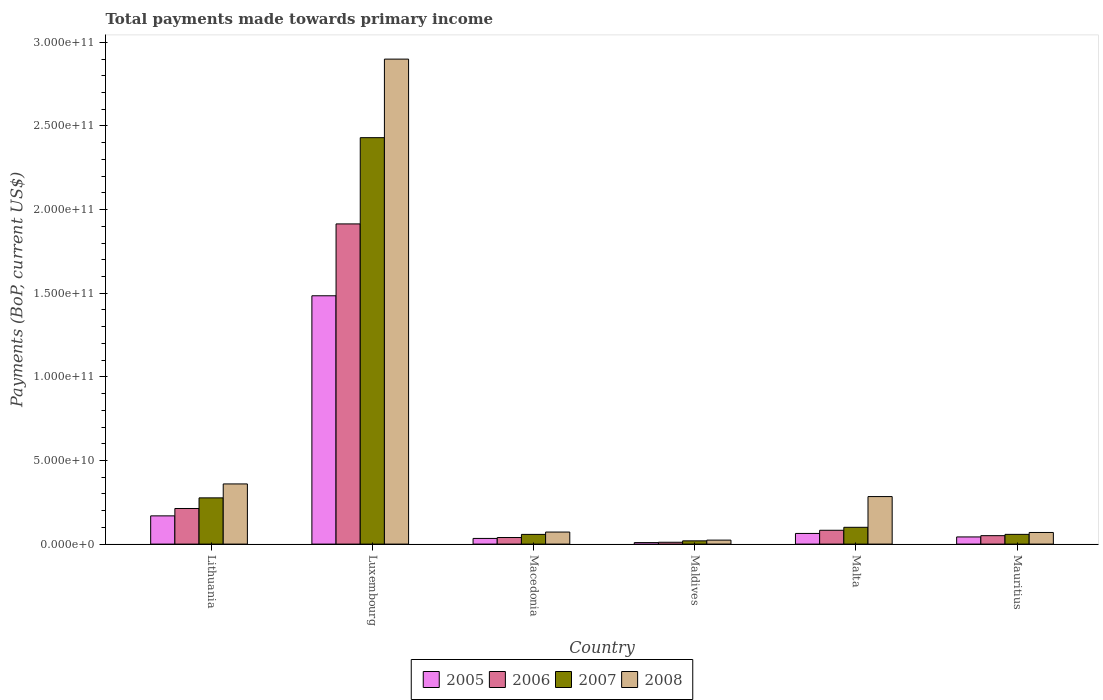How many groups of bars are there?
Offer a terse response. 6. Are the number of bars per tick equal to the number of legend labels?
Provide a succinct answer. Yes. Are the number of bars on each tick of the X-axis equal?
Keep it short and to the point. Yes. How many bars are there on the 1st tick from the right?
Provide a short and direct response. 4. What is the label of the 1st group of bars from the left?
Ensure brevity in your answer.  Lithuania. In how many cases, is the number of bars for a given country not equal to the number of legend labels?
Ensure brevity in your answer.  0. What is the total payments made towards primary income in 2005 in Maldives?
Provide a succinct answer. 9.10e+08. Across all countries, what is the maximum total payments made towards primary income in 2006?
Keep it short and to the point. 1.91e+11. Across all countries, what is the minimum total payments made towards primary income in 2005?
Give a very brief answer. 9.10e+08. In which country was the total payments made towards primary income in 2005 maximum?
Provide a short and direct response. Luxembourg. In which country was the total payments made towards primary income in 2008 minimum?
Offer a very short reply. Maldives. What is the total total payments made towards primary income in 2007 in the graph?
Your response must be concise. 2.94e+11. What is the difference between the total payments made towards primary income in 2007 in Lithuania and that in Mauritius?
Provide a succinct answer. 2.18e+1. What is the difference between the total payments made towards primary income in 2006 in Malta and the total payments made towards primary income in 2005 in Maldives?
Offer a very short reply. 7.35e+09. What is the average total payments made towards primary income in 2005 per country?
Keep it short and to the point. 3.00e+1. What is the difference between the total payments made towards primary income of/in 2008 and total payments made towards primary income of/in 2007 in Mauritius?
Provide a short and direct response. 1.13e+09. What is the ratio of the total payments made towards primary income in 2008 in Lithuania to that in Luxembourg?
Your response must be concise. 0.12. What is the difference between the highest and the second highest total payments made towards primary income in 2007?
Make the answer very short. 2.33e+11. What is the difference between the highest and the lowest total payments made towards primary income in 2007?
Offer a terse response. 2.41e+11. Is the sum of the total payments made towards primary income in 2008 in Luxembourg and Malta greater than the maximum total payments made towards primary income in 2007 across all countries?
Make the answer very short. Yes. Is it the case that in every country, the sum of the total payments made towards primary income in 2008 and total payments made towards primary income in 2007 is greater than the sum of total payments made towards primary income in 2005 and total payments made towards primary income in 2006?
Offer a very short reply. No. What does the 2nd bar from the left in Mauritius represents?
Keep it short and to the point. 2006. How many bars are there?
Ensure brevity in your answer.  24. Are all the bars in the graph horizontal?
Offer a terse response. No. How many countries are there in the graph?
Provide a short and direct response. 6. Are the values on the major ticks of Y-axis written in scientific E-notation?
Keep it short and to the point. Yes. Does the graph contain any zero values?
Provide a short and direct response. No. Where does the legend appear in the graph?
Your answer should be very brief. Bottom center. How are the legend labels stacked?
Give a very brief answer. Horizontal. What is the title of the graph?
Keep it short and to the point. Total payments made towards primary income. Does "1960" appear as one of the legend labels in the graph?
Your answer should be very brief. No. What is the label or title of the Y-axis?
Offer a terse response. Payments (BoP, current US$). What is the Payments (BoP, current US$) of 2005 in Lithuania?
Keep it short and to the point. 1.69e+1. What is the Payments (BoP, current US$) of 2006 in Lithuania?
Give a very brief answer. 2.13e+1. What is the Payments (BoP, current US$) of 2007 in Lithuania?
Your answer should be compact. 2.76e+1. What is the Payments (BoP, current US$) of 2008 in Lithuania?
Give a very brief answer. 3.60e+1. What is the Payments (BoP, current US$) in 2005 in Luxembourg?
Your answer should be compact. 1.48e+11. What is the Payments (BoP, current US$) in 2006 in Luxembourg?
Ensure brevity in your answer.  1.91e+11. What is the Payments (BoP, current US$) of 2007 in Luxembourg?
Keep it short and to the point. 2.43e+11. What is the Payments (BoP, current US$) in 2008 in Luxembourg?
Provide a succinct answer. 2.90e+11. What is the Payments (BoP, current US$) of 2005 in Macedonia?
Offer a terse response. 3.39e+09. What is the Payments (BoP, current US$) in 2006 in Macedonia?
Offer a terse response. 3.93e+09. What is the Payments (BoP, current US$) in 2007 in Macedonia?
Give a very brief answer. 5.80e+09. What is the Payments (BoP, current US$) of 2008 in Macedonia?
Provide a succinct answer. 7.21e+09. What is the Payments (BoP, current US$) of 2005 in Maldives?
Keep it short and to the point. 9.10e+08. What is the Payments (BoP, current US$) of 2006 in Maldives?
Offer a terse response. 1.10e+09. What is the Payments (BoP, current US$) of 2007 in Maldives?
Your answer should be very brief. 1.94e+09. What is the Payments (BoP, current US$) in 2008 in Maldives?
Make the answer very short. 2.38e+09. What is the Payments (BoP, current US$) of 2005 in Malta?
Provide a succinct answer. 6.37e+09. What is the Payments (BoP, current US$) in 2006 in Malta?
Ensure brevity in your answer.  8.26e+09. What is the Payments (BoP, current US$) in 2007 in Malta?
Provide a succinct answer. 1.00e+1. What is the Payments (BoP, current US$) of 2008 in Malta?
Offer a terse response. 2.84e+1. What is the Payments (BoP, current US$) of 2005 in Mauritius?
Offer a terse response. 4.28e+09. What is the Payments (BoP, current US$) of 2006 in Mauritius?
Give a very brief answer. 5.05e+09. What is the Payments (BoP, current US$) in 2007 in Mauritius?
Your answer should be compact. 5.82e+09. What is the Payments (BoP, current US$) of 2008 in Mauritius?
Your response must be concise. 6.95e+09. Across all countries, what is the maximum Payments (BoP, current US$) in 2005?
Offer a very short reply. 1.48e+11. Across all countries, what is the maximum Payments (BoP, current US$) in 2006?
Make the answer very short. 1.91e+11. Across all countries, what is the maximum Payments (BoP, current US$) of 2007?
Make the answer very short. 2.43e+11. Across all countries, what is the maximum Payments (BoP, current US$) in 2008?
Make the answer very short. 2.90e+11. Across all countries, what is the minimum Payments (BoP, current US$) of 2005?
Your answer should be compact. 9.10e+08. Across all countries, what is the minimum Payments (BoP, current US$) in 2006?
Provide a short and direct response. 1.10e+09. Across all countries, what is the minimum Payments (BoP, current US$) of 2007?
Offer a terse response. 1.94e+09. Across all countries, what is the minimum Payments (BoP, current US$) of 2008?
Provide a short and direct response. 2.38e+09. What is the total Payments (BoP, current US$) of 2005 in the graph?
Your response must be concise. 1.80e+11. What is the total Payments (BoP, current US$) of 2006 in the graph?
Provide a short and direct response. 2.31e+11. What is the total Payments (BoP, current US$) of 2007 in the graph?
Your response must be concise. 2.94e+11. What is the total Payments (BoP, current US$) of 2008 in the graph?
Your answer should be compact. 3.71e+11. What is the difference between the Payments (BoP, current US$) of 2005 in Lithuania and that in Luxembourg?
Your response must be concise. -1.32e+11. What is the difference between the Payments (BoP, current US$) in 2006 in Lithuania and that in Luxembourg?
Make the answer very short. -1.70e+11. What is the difference between the Payments (BoP, current US$) in 2007 in Lithuania and that in Luxembourg?
Your answer should be compact. -2.15e+11. What is the difference between the Payments (BoP, current US$) of 2008 in Lithuania and that in Luxembourg?
Your answer should be compact. -2.54e+11. What is the difference between the Payments (BoP, current US$) of 2005 in Lithuania and that in Macedonia?
Offer a very short reply. 1.35e+1. What is the difference between the Payments (BoP, current US$) of 2006 in Lithuania and that in Macedonia?
Your response must be concise. 1.74e+1. What is the difference between the Payments (BoP, current US$) of 2007 in Lithuania and that in Macedonia?
Ensure brevity in your answer.  2.18e+1. What is the difference between the Payments (BoP, current US$) in 2008 in Lithuania and that in Macedonia?
Provide a short and direct response. 2.88e+1. What is the difference between the Payments (BoP, current US$) of 2005 in Lithuania and that in Maldives?
Your answer should be very brief. 1.60e+1. What is the difference between the Payments (BoP, current US$) in 2006 in Lithuania and that in Maldives?
Your response must be concise. 2.02e+1. What is the difference between the Payments (BoP, current US$) of 2007 in Lithuania and that in Maldives?
Make the answer very short. 2.57e+1. What is the difference between the Payments (BoP, current US$) in 2008 in Lithuania and that in Maldives?
Your response must be concise. 3.36e+1. What is the difference between the Payments (BoP, current US$) in 2005 in Lithuania and that in Malta?
Your answer should be very brief. 1.05e+1. What is the difference between the Payments (BoP, current US$) in 2006 in Lithuania and that in Malta?
Your answer should be compact. 1.30e+1. What is the difference between the Payments (BoP, current US$) in 2007 in Lithuania and that in Malta?
Your answer should be compact. 1.76e+1. What is the difference between the Payments (BoP, current US$) in 2008 in Lithuania and that in Malta?
Give a very brief answer. 7.55e+09. What is the difference between the Payments (BoP, current US$) in 2005 in Lithuania and that in Mauritius?
Offer a terse response. 1.26e+1. What is the difference between the Payments (BoP, current US$) in 2006 in Lithuania and that in Mauritius?
Provide a succinct answer. 1.62e+1. What is the difference between the Payments (BoP, current US$) in 2007 in Lithuania and that in Mauritius?
Your answer should be compact. 2.18e+1. What is the difference between the Payments (BoP, current US$) of 2008 in Lithuania and that in Mauritius?
Your response must be concise. 2.90e+1. What is the difference between the Payments (BoP, current US$) of 2005 in Luxembourg and that in Macedonia?
Make the answer very short. 1.45e+11. What is the difference between the Payments (BoP, current US$) of 2006 in Luxembourg and that in Macedonia?
Your answer should be compact. 1.87e+11. What is the difference between the Payments (BoP, current US$) of 2007 in Luxembourg and that in Macedonia?
Keep it short and to the point. 2.37e+11. What is the difference between the Payments (BoP, current US$) of 2008 in Luxembourg and that in Macedonia?
Make the answer very short. 2.83e+11. What is the difference between the Payments (BoP, current US$) in 2005 in Luxembourg and that in Maldives?
Your answer should be very brief. 1.48e+11. What is the difference between the Payments (BoP, current US$) in 2006 in Luxembourg and that in Maldives?
Give a very brief answer. 1.90e+11. What is the difference between the Payments (BoP, current US$) in 2007 in Luxembourg and that in Maldives?
Offer a very short reply. 2.41e+11. What is the difference between the Payments (BoP, current US$) in 2008 in Luxembourg and that in Maldives?
Your response must be concise. 2.88e+11. What is the difference between the Payments (BoP, current US$) in 2005 in Luxembourg and that in Malta?
Your response must be concise. 1.42e+11. What is the difference between the Payments (BoP, current US$) in 2006 in Luxembourg and that in Malta?
Keep it short and to the point. 1.83e+11. What is the difference between the Payments (BoP, current US$) in 2007 in Luxembourg and that in Malta?
Offer a terse response. 2.33e+11. What is the difference between the Payments (BoP, current US$) of 2008 in Luxembourg and that in Malta?
Make the answer very short. 2.62e+11. What is the difference between the Payments (BoP, current US$) of 2005 in Luxembourg and that in Mauritius?
Your answer should be very brief. 1.44e+11. What is the difference between the Payments (BoP, current US$) of 2006 in Luxembourg and that in Mauritius?
Provide a succinct answer. 1.86e+11. What is the difference between the Payments (BoP, current US$) of 2007 in Luxembourg and that in Mauritius?
Make the answer very short. 2.37e+11. What is the difference between the Payments (BoP, current US$) of 2008 in Luxembourg and that in Mauritius?
Ensure brevity in your answer.  2.83e+11. What is the difference between the Payments (BoP, current US$) of 2005 in Macedonia and that in Maldives?
Give a very brief answer. 2.48e+09. What is the difference between the Payments (BoP, current US$) in 2006 in Macedonia and that in Maldives?
Provide a short and direct response. 2.83e+09. What is the difference between the Payments (BoP, current US$) of 2007 in Macedonia and that in Maldives?
Ensure brevity in your answer.  3.86e+09. What is the difference between the Payments (BoP, current US$) in 2008 in Macedonia and that in Maldives?
Offer a terse response. 4.83e+09. What is the difference between the Payments (BoP, current US$) of 2005 in Macedonia and that in Malta?
Your answer should be compact. -2.97e+09. What is the difference between the Payments (BoP, current US$) in 2006 in Macedonia and that in Malta?
Ensure brevity in your answer.  -4.33e+09. What is the difference between the Payments (BoP, current US$) in 2007 in Macedonia and that in Malta?
Offer a terse response. -4.24e+09. What is the difference between the Payments (BoP, current US$) in 2008 in Macedonia and that in Malta?
Make the answer very short. -2.12e+1. What is the difference between the Payments (BoP, current US$) in 2005 in Macedonia and that in Mauritius?
Your answer should be compact. -8.91e+08. What is the difference between the Payments (BoP, current US$) of 2006 in Macedonia and that in Mauritius?
Provide a short and direct response. -1.12e+09. What is the difference between the Payments (BoP, current US$) in 2007 in Macedonia and that in Mauritius?
Your answer should be compact. -1.97e+07. What is the difference between the Payments (BoP, current US$) in 2008 in Macedonia and that in Mauritius?
Offer a very short reply. 2.59e+08. What is the difference between the Payments (BoP, current US$) of 2005 in Maldives and that in Malta?
Your answer should be very brief. -5.46e+09. What is the difference between the Payments (BoP, current US$) in 2006 in Maldives and that in Malta?
Keep it short and to the point. -7.16e+09. What is the difference between the Payments (BoP, current US$) of 2007 in Maldives and that in Malta?
Your response must be concise. -8.10e+09. What is the difference between the Payments (BoP, current US$) in 2008 in Maldives and that in Malta?
Offer a terse response. -2.60e+1. What is the difference between the Payments (BoP, current US$) of 2005 in Maldives and that in Mauritius?
Give a very brief answer. -3.37e+09. What is the difference between the Payments (BoP, current US$) of 2006 in Maldives and that in Mauritius?
Your answer should be very brief. -3.95e+09. What is the difference between the Payments (BoP, current US$) in 2007 in Maldives and that in Mauritius?
Give a very brief answer. -3.88e+09. What is the difference between the Payments (BoP, current US$) of 2008 in Maldives and that in Mauritius?
Provide a short and direct response. -4.57e+09. What is the difference between the Payments (BoP, current US$) in 2005 in Malta and that in Mauritius?
Offer a terse response. 2.08e+09. What is the difference between the Payments (BoP, current US$) of 2006 in Malta and that in Mauritius?
Make the answer very short. 3.21e+09. What is the difference between the Payments (BoP, current US$) in 2007 in Malta and that in Mauritius?
Offer a very short reply. 4.22e+09. What is the difference between the Payments (BoP, current US$) of 2008 in Malta and that in Mauritius?
Your response must be concise. 2.15e+1. What is the difference between the Payments (BoP, current US$) of 2005 in Lithuania and the Payments (BoP, current US$) of 2006 in Luxembourg?
Offer a very short reply. -1.75e+11. What is the difference between the Payments (BoP, current US$) of 2005 in Lithuania and the Payments (BoP, current US$) of 2007 in Luxembourg?
Make the answer very short. -2.26e+11. What is the difference between the Payments (BoP, current US$) in 2005 in Lithuania and the Payments (BoP, current US$) in 2008 in Luxembourg?
Keep it short and to the point. -2.73e+11. What is the difference between the Payments (BoP, current US$) of 2006 in Lithuania and the Payments (BoP, current US$) of 2007 in Luxembourg?
Provide a short and direct response. -2.22e+11. What is the difference between the Payments (BoP, current US$) in 2006 in Lithuania and the Payments (BoP, current US$) in 2008 in Luxembourg?
Your response must be concise. -2.69e+11. What is the difference between the Payments (BoP, current US$) of 2007 in Lithuania and the Payments (BoP, current US$) of 2008 in Luxembourg?
Provide a short and direct response. -2.62e+11. What is the difference between the Payments (BoP, current US$) in 2005 in Lithuania and the Payments (BoP, current US$) in 2006 in Macedonia?
Ensure brevity in your answer.  1.29e+1. What is the difference between the Payments (BoP, current US$) in 2005 in Lithuania and the Payments (BoP, current US$) in 2007 in Macedonia?
Give a very brief answer. 1.11e+1. What is the difference between the Payments (BoP, current US$) in 2005 in Lithuania and the Payments (BoP, current US$) in 2008 in Macedonia?
Provide a succinct answer. 9.67e+09. What is the difference between the Payments (BoP, current US$) of 2006 in Lithuania and the Payments (BoP, current US$) of 2007 in Macedonia?
Make the answer very short. 1.55e+1. What is the difference between the Payments (BoP, current US$) in 2006 in Lithuania and the Payments (BoP, current US$) in 2008 in Macedonia?
Offer a terse response. 1.41e+1. What is the difference between the Payments (BoP, current US$) of 2007 in Lithuania and the Payments (BoP, current US$) of 2008 in Macedonia?
Provide a succinct answer. 2.04e+1. What is the difference between the Payments (BoP, current US$) in 2005 in Lithuania and the Payments (BoP, current US$) in 2006 in Maldives?
Offer a very short reply. 1.58e+1. What is the difference between the Payments (BoP, current US$) of 2005 in Lithuania and the Payments (BoP, current US$) of 2007 in Maldives?
Make the answer very short. 1.49e+1. What is the difference between the Payments (BoP, current US$) in 2005 in Lithuania and the Payments (BoP, current US$) in 2008 in Maldives?
Provide a succinct answer. 1.45e+1. What is the difference between the Payments (BoP, current US$) in 2006 in Lithuania and the Payments (BoP, current US$) in 2007 in Maldives?
Provide a short and direct response. 1.93e+1. What is the difference between the Payments (BoP, current US$) in 2006 in Lithuania and the Payments (BoP, current US$) in 2008 in Maldives?
Keep it short and to the point. 1.89e+1. What is the difference between the Payments (BoP, current US$) in 2007 in Lithuania and the Payments (BoP, current US$) in 2008 in Maldives?
Offer a terse response. 2.53e+1. What is the difference between the Payments (BoP, current US$) of 2005 in Lithuania and the Payments (BoP, current US$) of 2006 in Malta?
Your answer should be compact. 8.62e+09. What is the difference between the Payments (BoP, current US$) of 2005 in Lithuania and the Payments (BoP, current US$) of 2007 in Malta?
Provide a succinct answer. 6.84e+09. What is the difference between the Payments (BoP, current US$) of 2005 in Lithuania and the Payments (BoP, current US$) of 2008 in Malta?
Offer a very short reply. -1.15e+1. What is the difference between the Payments (BoP, current US$) of 2006 in Lithuania and the Payments (BoP, current US$) of 2007 in Malta?
Offer a very short reply. 1.12e+1. What is the difference between the Payments (BoP, current US$) in 2006 in Lithuania and the Payments (BoP, current US$) in 2008 in Malta?
Offer a very short reply. -7.13e+09. What is the difference between the Payments (BoP, current US$) in 2007 in Lithuania and the Payments (BoP, current US$) in 2008 in Malta?
Your answer should be very brief. -7.77e+08. What is the difference between the Payments (BoP, current US$) of 2005 in Lithuania and the Payments (BoP, current US$) of 2006 in Mauritius?
Give a very brief answer. 1.18e+1. What is the difference between the Payments (BoP, current US$) in 2005 in Lithuania and the Payments (BoP, current US$) in 2007 in Mauritius?
Offer a terse response. 1.11e+1. What is the difference between the Payments (BoP, current US$) in 2005 in Lithuania and the Payments (BoP, current US$) in 2008 in Mauritius?
Give a very brief answer. 9.93e+09. What is the difference between the Payments (BoP, current US$) of 2006 in Lithuania and the Payments (BoP, current US$) of 2007 in Mauritius?
Provide a succinct answer. 1.55e+1. What is the difference between the Payments (BoP, current US$) of 2006 in Lithuania and the Payments (BoP, current US$) of 2008 in Mauritius?
Offer a very short reply. 1.43e+1. What is the difference between the Payments (BoP, current US$) of 2007 in Lithuania and the Payments (BoP, current US$) of 2008 in Mauritius?
Your answer should be very brief. 2.07e+1. What is the difference between the Payments (BoP, current US$) of 2005 in Luxembourg and the Payments (BoP, current US$) of 2006 in Macedonia?
Offer a terse response. 1.45e+11. What is the difference between the Payments (BoP, current US$) of 2005 in Luxembourg and the Payments (BoP, current US$) of 2007 in Macedonia?
Offer a very short reply. 1.43e+11. What is the difference between the Payments (BoP, current US$) in 2005 in Luxembourg and the Payments (BoP, current US$) in 2008 in Macedonia?
Make the answer very short. 1.41e+11. What is the difference between the Payments (BoP, current US$) of 2006 in Luxembourg and the Payments (BoP, current US$) of 2007 in Macedonia?
Your answer should be very brief. 1.86e+11. What is the difference between the Payments (BoP, current US$) of 2006 in Luxembourg and the Payments (BoP, current US$) of 2008 in Macedonia?
Provide a succinct answer. 1.84e+11. What is the difference between the Payments (BoP, current US$) of 2007 in Luxembourg and the Payments (BoP, current US$) of 2008 in Macedonia?
Offer a terse response. 2.36e+11. What is the difference between the Payments (BoP, current US$) of 2005 in Luxembourg and the Payments (BoP, current US$) of 2006 in Maldives?
Your answer should be very brief. 1.47e+11. What is the difference between the Payments (BoP, current US$) in 2005 in Luxembourg and the Payments (BoP, current US$) in 2007 in Maldives?
Offer a very short reply. 1.47e+11. What is the difference between the Payments (BoP, current US$) in 2005 in Luxembourg and the Payments (BoP, current US$) in 2008 in Maldives?
Offer a terse response. 1.46e+11. What is the difference between the Payments (BoP, current US$) in 2006 in Luxembourg and the Payments (BoP, current US$) in 2007 in Maldives?
Ensure brevity in your answer.  1.89e+11. What is the difference between the Payments (BoP, current US$) of 2006 in Luxembourg and the Payments (BoP, current US$) of 2008 in Maldives?
Provide a short and direct response. 1.89e+11. What is the difference between the Payments (BoP, current US$) in 2007 in Luxembourg and the Payments (BoP, current US$) in 2008 in Maldives?
Your response must be concise. 2.41e+11. What is the difference between the Payments (BoP, current US$) in 2005 in Luxembourg and the Payments (BoP, current US$) in 2006 in Malta?
Keep it short and to the point. 1.40e+11. What is the difference between the Payments (BoP, current US$) of 2005 in Luxembourg and the Payments (BoP, current US$) of 2007 in Malta?
Your response must be concise. 1.38e+11. What is the difference between the Payments (BoP, current US$) of 2005 in Luxembourg and the Payments (BoP, current US$) of 2008 in Malta?
Provide a short and direct response. 1.20e+11. What is the difference between the Payments (BoP, current US$) of 2006 in Luxembourg and the Payments (BoP, current US$) of 2007 in Malta?
Offer a terse response. 1.81e+11. What is the difference between the Payments (BoP, current US$) in 2006 in Luxembourg and the Payments (BoP, current US$) in 2008 in Malta?
Your answer should be compact. 1.63e+11. What is the difference between the Payments (BoP, current US$) in 2007 in Luxembourg and the Payments (BoP, current US$) in 2008 in Malta?
Give a very brief answer. 2.15e+11. What is the difference between the Payments (BoP, current US$) in 2005 in Luxembourg and the Payments (BoP, current US$) in 2006 in Mauritius?
Give a very brief answer. 1.43e+11. What is the difference between the Payments (BoP, current US$) of 2005 in Luxembourg and the Payments (BoP, current US$) of 2007 in Mauritius?
Offer a terse response. 1.43e+11. What is the difference between the Payments (BoP, current US$) in 2005 in Luxembourg and the Payments (BoP, current US$) in 2008 in Mauritius?
Provide a succinct answer. 1.42e+11. What is the difference between the Payments (BoP, current US$) in 2006 in Luxembourg and the Payments (BoP, current US$) in 2007 in Mauritius?
Your answer should be compact. 1.86e+11. What is the difference between the Payments (BoP, current US$) of 2006 in Luxembourg and the Payments (BoP, current US$) of 2008 in Mauritius?
Offer a terse response. 1.84e+11. What is the difference between the Payments (BoP, current US$) of 2007 in Luxembourg and the Payments (BoP, current US$) of 2008 in Mauritius?
Offer a terse response. 2.36e+11. What is the difference between the Payments (BoP, current US$) in 2005 in Macedonia and the Payments (BoP, current US$) in 2006 in Maldives?
Keep it short and to the point. 2.29e+09. What is the difference between the Payments (BoP, current US$) in 2005 in Macedonia and the Payments (BoP, current US$) in 2007 in Maldives?
Your response must be concise. 1.45e+09. What is the difference between the Payments (BoP, current US$) of 2005 in Macedonia and the Payments (BoP, current US$) of 2008 in Maldives?
Keep it short and to the point. 1.01e+09. What is the difference between the Payments (BoP, current US$) of 2006 in Macedonia and the Payments (BoP, current US$) of 2007 in Maldives?
Provide a short and direct response. 1.99e+09. What is the difference between the Payments (BoP, current US$) in 2006 in Macedonia and the Payments (BoP, current US$) in 2008 in Maldives?
Your answer should be very brief. 1.55e+09. What is the difference between the Payments (BoP, current US$) of 2007 in Macedonia and the Payments (BoP, current US$) of 2008 in Maldives?
Your answer should be very brief. 3.42e+09. What is the difference between the Payments (BoP, current US$) in 2005 in Macedonia and the Payments (BoP, current US$) in 2006 in Malta?
Your answer should be very brief. -4.87e+09. What is the difference between the Payments (BoP, current US$) of 2005 in Macedonia and the Payments (BoP, current US$) of 2007 in Malta?
Your response must be concise. -6.65e+09. What is the difference between the Payments (BoP, current US$) in 2005 in Macedonia and the Payments (BoP, current US$) in 2008 in Malta?
Keep it short and to the point. -2.50e+1. What is the difference between the Payments (BoP, current US$) of 2006 in Macedonia and the Payments (BoP, current US$) of 2007 in Malta?
Your answer should be very brief. -6.11e+09. What is the difference between the Payments (BoP, current US$) of 2006 in Macedonia and the Payments (BoP, current US$) of 2008 in Malta?
Give a very brief answer. -2.45e+1. What is the difference between the Payments (BoP, current US$) of 2007 in Macedonia and the Payments (BoP, current US$) of 2008 in Malta?
Make the answer very short. -2.26e+1. What is the difference between the Payments (BoP, current US$) of 2005 in Macedonia and the Payments (BoP, current US$) of 2006 in Mauritius?
Give a very brief answer. -1.66e+09. What is the difference between the Payments (BoP, current US$) in 2005 in Macedonia and the Payments (BoP, current US$) in 2007 in Mauritius?
Provide a short and direct response. -2.43e+09. What is the difference between the Payments (BoP, current US$) in 2005 in Macedonia and the Payments (BoP, current US$) in 2008 in Mauritius?
Provide a short and direct response. -3.55e+09. What is the difference between the Payments (BoP, current US$) of 2006 in Macedonia and the Payments (BoP, current US$) of 2007 in Mauritius?
Provide a short and direct response. -1.89e+09. What is the difference between the Payments (BoP, current US$) in 2006 in Macedonia and the Payments (BoP, current US$) in 2008 in Mauritius?
Offer a very short reply. -3.02e+09. What is the difference between the Payments (BoP, current US$) in 2007 in Macedonia and the Payments (BoP, current US$) in 2008 in Mauritius?
Provide a short and direct response. -1.15e+09. What is the difference between the Payments (BoP, current US$) of 2005 in Maldives and the Payments (BoP, current US$) of 2006 in Malta?
Provide a short and direct response. -7.35e+09. What is the difference between the Payments (BoP, current US$) in 2005 in Maldives and the Payments (BoP, current US$) in 2007 in Malta?
Keep it short and to the point. -9.13e+09. What is the difference between the Payments (BoP, current US$) of 2005 in Maldives and the Payments (BoP, current US$) of 2008 in Malta?
Your response must be concise. -2.75e+1. What is the difference between the Payments (BoP, current US$) of 2006 in Maldives and the Payments (BoP, current US$) of 2007 in Malta?
Your answer should be compact. -8.94e+09. What is the difference between the Payments (BoP, current US$) in 2006 in Maldives and the Payments (BoP, current US$) in 2008 in Malta?
Provide a short and direct response. -2.73e+1. What is the difference between the Payments (BoP, current US$) in 2007 in Maldives and the Payments (BoP, current US$) in 2008 in Malta?
Give a very brief answer. -2.65e+1. What is the difference between the Payments (BoP, current US$) of 2005 in Maldives and the Payments (BoP, current US$) of 2006 in Mauritius?
Make the answer very short. -4.14e+09. What is the difference between the Payments (BoP, current US$) in 2005 in Maldives and the Payments (BoP, current US$) in 2007 in Mauritius?
Your answer should be very brief. -4.91e+09. What is the difference between the Payments (BoP, current US$) of 2005 in Maldives and the Payments (BoP, current US$) of 2008 in Mauritius?
Your response must be concise. -6.04e+09. What is the difference between the Payments (BoP, current US$) in 2006 in Maldives and the Payments (BoP, current US$) in 2007 in Mauritius?
Offer a very short reply. -4.72e+09. What is the difference between the Payments (BoP, current US$) of 2006 in Maldives and the Payments (BoP, current US$) of 2008 in Mauritius?
Offer a very short reply. -5.84e+09. What is the difference between the Payments (BoP, current US$) in 2007 in Maldives and the Payments (BoP, current US$) in 2008 in Mauritius?
Your response must be concise. -5.00e+09. What is the difference between the Payments (BoP, current US$) in 2005 in Malta and the Payments (BoP, current US$) in 2006 in Mauritius?
Ensure brevity in your answer.  1.32e+09. What is the difference between the Payments (BoP, current US$) of 2005 in Malta and the Payments (BoP, current US$) of 2007 in Mauritius?
Give a very brief answer. 5.49e+08. What is the difference between the Payments (BoP, current US$) of 2005 in Malta and the Payments (BoP, current US$) of 2008 in Mauritius?
Ensure brevity in your answer.  -5.81e+08. What is the difference between the Payments (BoP, current US$) in 2006 in Malta and the Payments (BoP, current US$) in 2007 in Mauritius?
Provide a succinct answer. 2.45e+09. What is the difference between the Payments (BoP, current US$) of 2006 in Malta and the Payments (BoP, current US$) of 2008 in Mauritius?
Offer a very short reply. 1.32e+09. What is the difference between the Payments (BoP, current US$) of 2007 in Malta and the Payments (BoP, current US$) of 2008 in Mauritius?
Provide a succinct answer. 3.09e+09. What is the average Payments (BoP, current US$) in 2005 per country?
Keep it short and to the point. 3.00e+1. What is the average Payments (BoP, current US$) of 2006 per country?
Offer a very short reply. 3.85e+1. What is the average Payments (BoP, current US$) of 2007 per country?
Ensure brevity in your answer.  4.90e+1. What is the average Payments (BoP, current US$) of 2008 per country?
Make the answer very short. 6.18e+1. What is the difference between the Payments (BoP, current US$) of 2005 and Payments (BoP, current US$) of 2006 in Lithuania?
Ensure brevity in your answer.  -4.41e+09. What is the difference between the Payments (BoP, current US$) in 2005 and Payments (BoP, current US$) in 2007 in Lithuania?
Give a very brief answer. -1.08e+1. What is the difference between the Payments (BoP, current US$) of 2005 and Payments (BoP, current US$) of 2008 in Lithuania?
Your answer should be very brief. -1.91e+1. What is the difference between the Payments (BoP, current US$) of 2006 and Payments (BoP, current US$) of 2007 in Lithuania?
Give a very brief answer. -6.35e+09. What is the difference between the Payments (BoP, current US$) of 2006 and Payments (BoP, current US$) of 2008 in Lithuania?
Provide a short and direct response. -1.47e+1. What is the difference between the Payments (BoP, current US$) in 2007 and Payments (BoP, current US$) in 2008 in Lithuania?
Your answer should be very brief. -8.33e+09. What is the difference between the Payments (BoP, current US$) in 2005 and Payments (BoP, current US$) in 2006 in Luxembourg?
Your answer should be very brief. -4.30e+1. What is the difference between the Payments (BoP, current US$) of 2005 and Payments (BoP, current US$) of 2007 in Luxembourg?
Your response must be concise. -9.45e+1. What is the difference between the Payments (BoP, current US$) in 2005 and Payments (BoP, current US$) in 2008 in Luxembourg?
Ensure brevity in your answer.  -1.41e+11. What is the difference between the Payments (BoP, current US$) in 2006 and Payments (BoP, current US$) in 2007 in Luxembourg?
Offer a very short reply. -5.16e+1. What is the difference between the Payments (BoP, current US$) in 2006 and Payments (BoP, current US$) in 2008 in Luxembourg?
Keep it short and to the point. -9.85e+1. What is the difference between the Payments (BoP, current US$) of 2007 and Payments (BoP, current US$) of 2008 in Luxembourg?
Your answer should be very brief. -4.70e+1. What is the difference between the Payments (BoP, current US$) in 2005 and Payments (BoP, current US$) in 2006 in Macedonia?
Your answer should be compact. -5.40e+08. What is the difference between the Payments (BoP, current US$) of 2005 and Payments (BoP, current US$) of 2007 in Macedonia?
Give a very brief answer. -2.41e+09. What is the difference between the Payments (BoP, current US$) in 2005 and Payments (BoP, current US$) in 2008 in Macedonia?
Offer a very short reply. -3.81e+09. What is the difference between the Payments (BoP, current US$) of 2006 and Payments (BoP, current US$) of 2007 in Macedonia?
Your response must be concise. -1.87e+09. What is the difference between the Payments (BoP, current US$) in 2006 and Payments (BoP, current US$) in 2008 in Macedonia?
Offer a terse response. -3.27e+09. What is the difference between the Payments (BoP, current US$) of 2007 and Payments (BoP, current US$) of 2008 in Macedonia?
Offer a very short reply. -1.41e+09. What is the difference between the Payments (BoP, current US$) of 2005 and Payments (BoP, current US$) of 2006 in Maldives?
Provide a short and direct response. -1.92e+08. What is the difference between the Payments (BoP, current US$) of 2005 and Payments (BoP, current US$) of 2007 in Maldives?
Your response must be concise. -1.03e+09. What is the difference between the Payments (BoP, current US$) in 2005 and Payments (BoP, current US$) in 2008 in Maldives?
Your answer should be compact. -1.47e+09. What is the difference between the Payments (BoP, current US$) in 2006 and Payments (BoP, current US$) in 2007 in Maldives?
Offer a terse response. -8.40e+08. What is the difference between the Payments (BoP, current US$) in 2006 and Payments (BoP, current US$) in 2008 in Maldives?
Make the answer very short. -1.28e+09. What is the difference between the Payments (BoP, current US$) of 2007 and Payments (BoP, current US$) of 2008 in Maldives?
Offer a very short reply. -4.38e+08. What is the difference between the Payments (BoP, current US$) in 2005 and Payments (BoP, current US$) in 2006 in Malta?
Offer a very short reply. -1.90e+09. What is the difference between the Payments (BoP, current US$) in 2005 and Payments (BoP, current US$) in 2007 in Malta?
Provide a succinct answer. -3.67e+09. What is the difference between the Payments (BoP, current US$) of 2005 and Payments (BoP, current US$) of 2008 in Malta?
Make the answer very short. -2.21e+1. What is the difference between the Payments (BoP, current US$) in 2006 and Payments (BoP, current US$) in 2007 in Malta?
Your answer should be compact. -1.78e+09. What is the difference between the Payments (BoP, current US$) in 2006 and Payments (BoP, current US$) in 2008 in Malta?
Ensure brevity in your answer.  -2.02e+1. What is the difference between the Payments (BoP, current US$) of 2007 and Payments (BoP, current US$) of 2008 in Malta?
Offer a terse response. -1.84e+1. What is the difference between the Payments (BoP, current US$) in 2005 and Payments (BoP, current US$) in 2006 in Mauritius?
Give a very brief answer. -7.65e+08. What is the difference between the Payments (BoP, current US$) of 2005 and Payments (BoP, current US$) of 2007 in Mauritius?
Make the answer very short. -1.53e+09. What is the difference between the Payments (BoP, current US$) in 2005 and Payments (BoP, current US$) in 2008 in Mauritius?
Your answer should be very brief. -2.66e+09. What is the difference between the Payments (BoP, current US$) of 2006 and Payments (BoP, current US$) of 2007 in Mauritius?
Your answer should be compact. -7.69e+08. What is the difference between the Payments (BoP, current US$) in 2006 and Payments (BoP, current US$) in 2008 in Mauritius?
Make the answer very short. -1.90e+09. What is the difference between the Payments (BoP, current US$) in 2007 and Payments (BoP, current US$) in 2008 in Mauritius?
Ensure brevity in your answer.  -1.13e+09. What is the ratio of the Payments (BoP, current US$) of 2005 in Lithuania to that in Luxembourg?
Provide a short and direct response. 0.11. What is the ratio of the Payments (BoP, current US$) in 2006 in Lithuania to that in Luxembourg?
Make the answer very short. 0.11. What is the ratio of the Payments (BoP, current US$) of 2007 in Lithuania to that in Luxembourg?
Provide a short and direct response. 0.11. What is the ratio of the Payments (BoP, current US$) of 2008 in Lithuania to that in Luxembourg?
Your response must be concise. 0.12. What is the ratio of the Payments (BoP, current US$) of 2005 in Lithuania to that in Macedonia?
Offer a very short reply. 4.98. What is the ratio of the Payments (BoP, current US$) in 2006 in Lithuania to that in Macedonia?
Offer a very short reply. 5.41. What is the ratio of the Payments (BoP, current US$) in 2007 in Lithuania to that in Macedonia?
Provide a short and direct response. 4.77. What is the ratio of the Payments (BoP, current US$) of 2008 in Lithuania to that in Macedonia?
Ensure brevity in your answer.  4.99. What is the ratio of the Payments (BoP, current US$) of 2005 in Lithuania to that in Maldives?
Keep it short and to the point. 18.54. What is the ratio of the Payments (BoP, current US$) in 2006 in Lithuania to that in Maldives?
Your answer should be very brief. 19.31. What is the ratio of the Payments (BoP, current US$) in 2007 in Lithuania to that in Maldives?
Make the answer very short. 14.23. What is the ratio of the Payments (BoP, current US$) of 2008 in Lithuania to that in Maldives?
Your response must be concise. 15.11. What is the ratio of the Payments (BoP, current US$) in 2005 in Lithuania to that in Malta?
Your response must be concise. 2.65. What is the ratio of the Payments (BoP, current US$) in 2006 in Lithuania to that in Malta?
Offer a terse response. 2.58. What is the ratio of the Payments (BoP, current US$) in 2007 in Lithuania to that in Malta?
Your answer should be compact. 2.75. What is the ratio of the Payments (BoP, current US$) in 2008 in Lithuania to that in Malta?
Provide a short and direct response. 1.27. What is the ratio of the Payments (BoP, current US$) in 2005 in Lithuania to that in Mauritius?
Ensure brevity in your answer.  3.94. What is the ratio of the Payments (BoP, current US$) in 2006 in Lithuania to that in Mauritius?
Keep it short and to the point. 4.22. What is the ratio of the Payments (BoP, current US$) in 2007 in Lithuania to that in Mauritius?
Provide a short and direct response. 4.75. What is the ratio of the Payments (BoP, current US$) in 2008 in Lithuania to that in Mauritius?
Provide a succinct answer. 5.18. What is the ratio of the Payments (BoP, current US$) of 2005 in Luxembourg to that in Macedonia?
Your answer should be very brief. 43.76. What is the ratio of the Payments (BoP, current US$) of 2006 in Luxembourg to that in Macedonia?
Your answer should be very brief. 48.68. What is the ratio of the Payments (BoP, current US$) in 2007 in Luxembourg to that in Macedonia?
Your answer should be compact. 41.91. What is the ratio of the Payments (BoP, current US$) in 2008 in Luxembourg to that in Macedonia?
Provide a succinct answer. 40.24. What is the ratio of the Payments (BoP, current US$) in 2005 in Luxembourg to that in Maldives?
Your response must be concise. 163.08. What is the ratio of the Payments (BoP, current US$) of 2006 in Luxembourg to that in Maldives?
Make the answer very short. 173.58. What is the ratio of the Payments (BoP, current US$) in 2007 in Luxembourg to that in Maldives?
Your response must be concise. 125.06. What is the ratio of the Payments (BoP, current US$) in 2008 in Luxembourg to that in Maldives?
Offer a very short reply. 121.79. What is the ratio of the Payments (BoP, current US$) of 2005 in Luxembourg to that in Malta?
Provide a short and direct response. 23.32. What is the ratio of the Payments (BoP, current US$) of 2006 in Luxembourg to that in Malta?
Keep it short and to the point. 23.16. What is the ratio of the Payments (BoP, current US$) in 2007 in Luxembourg to that in Malta?
Make the answer very short. 24.2. What is the ratio of the Payments (BoP, current US$) of 2008 in Luxembourg to that in Malta?
Your answer should be compact. 10.2. What is the ratio of the Payments (BoP, current US$) in 2005 in Luxembourg to that in Mauritius?
Offer a terse response. 34.65. What is the ratio of the Payments (BoP, current US$) in 2006 in Luxembourg to that in Mauritius?
Make the answer very short. 37.91. What is the ratio of the Payments (BoP, current US$) of 2007 in Luxembourg to that in Mauritius?
Give a very brief answer. 41.76. What is the ratio of the Payments (BoP, current US$) of 2008 in Luxembourg to that in Mauritius?
Offer a very short reply. 41.73. What is the ratio of the Payments (BoP, current US$) of 2005 in Macedonia to that in Maldives?
Ensure brevity in your answer.  3.73. What is the ratio of the Payments (BoP, current US$) of 2006 in Macedonia to that in Maldives?
Your answer should be compact. 3.57. What is the ratio of the Payments (BoP, current US$) of 2007 in Macedonia to that in Maldives?
Ensure brevity in your answer.  2.98. What is the ratio of the Payments (BoP, current US$) of 2008 in Macedonia to that in Maldives?
Your answer should be very brief. 3.03. What is the ratio of the Payments (BoP, current US$) in 2005 in Macedonia to that in Malta?
Provide a succinct answer. 0.53. What is the ratio of the Payments (BoP, current US$) in 2006 in Macedonia to that in Malta?
Provide a short and direct response. 0.48. What is the ratio of the Payments (BoP, current US$) in 2007 in Macedonia to that in Malta?
Your answer should be very brief. 0.58. What is the ratio of the Payments (BoP, current US$) in 2008 in Macedonia to that in Malta?
Provide a short and direct response. 0.25. What is the ratio of the Payments (BoP, current US$) of 2005 in Macedonia to that in Mauritius?
Your response must be concise. 0.79. What is the ratio of the Payments (BoP, current US$) of 2006 in Macedonia to that in Mauritius?
Offer a very short reply. 0.78. What is the ratio of the Payments (BoP, current US$) of 2007 in Macedonia to that in Mauritius?
Keep it short and to the point. 1. What is the ratio of the Payments (BoP, current US$) of 2008 in Macedonia to that in Mauritius?
Your answer should be very brief. 1.04. What is the ratio of the Payments (BoP, current US$) of 2005 in Maldives to that in Malta?
Ensure brevity in your answer.  0.14. What is the ratio of the Payments (BoP, current US$) of 2006 in Maldives to that in Malta?
Your answer should be compact. 0.13. What is the ratio of the Payments (BoP, current US$) in 2007 in Maldives to that in Malta?
Ensure brevity in your answer.  0.19. What is the ratio of the Payments (BoP, current US$) in 2008 in Maldives to that in Malta?
Your response must be concise. 0.08. What is the ratio of the Payments (BoP, current US$) in 2005 in Maldives to that in Mauritius?
Provide a succinct answer. 0.21. What is the ratio of the Payments (BoP, current US$) of 2006 in Maldives to that in Mauritius?
Your response must be concise. 0.22. What is the ratio of the Payments (BoP, current US$) of 2007 in Maldives to that in Mauritius?
Make the answer very short. 0.33. What is the ratio of the Payments (BoP, current US$) in 2008 in Maldives to that in Mauritius?
Give a very brief answer. 0.34. What is the ratio of the Payments (BoP, current US$) in 2005 in Malta to that in Mauritius?
Offer a terse response. 1.49. What is the ratio of the Payments (BoP, current US$) of 2006 in Malta to that in Mauritius?
Your answer should be very brief. 1.64. What is the ratio of the Payments (BoP, current US$) of 2007 in Malta to that in Mauritius?
Provide a succinct answer. 1.73. What is the ratio of the Payments (BoP, current US$) of 2008 in Malta to that in Mauritius?
Your answer should be very brief. 4.09. What is the difference between the highest and the second highest Payments (BoP, current US$) in 2005?
Your response must be concise. 1.32e+11. What is the difference between the highest and the second highest Payments (BoP, current US$) of 2006?
Offer a very short reply. 1.70e+11. What is the difference between the highest and the second highest Payments (BoP, current US$) of 2007?
Provide a succinct answer. 2.15e+11. What is the difference between the highest and the second highest Payments (BoP, current US$) of 2008?
Keep it short and to the point. 2.54e+11. What is the difference between the highest and the lowest Payments (BoP, current US$) in 2005?
Offer a terse response. 1.48e+11. What is the difference between the highest and the lowest Payments (BoP, current US$) in 2006?
Make the answer very short. 1.90e+11. What is the difference between the highest and the lowest Payments (BoP, current US$) in 2007?
Provide a short and direct response. 2.41e+11. What is the difference between the highest and the lowest Payments (BoP, current US$) in 2008?
Offer a very short reply. 2.88e+11. 